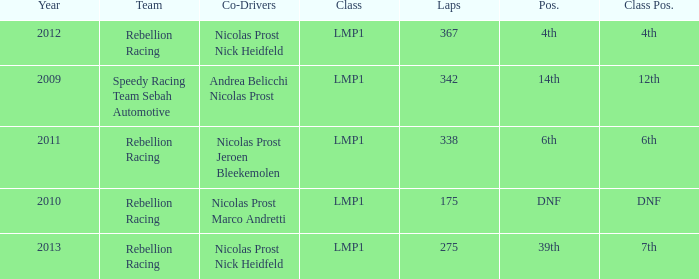What is Class Pos., when Year is before 2013, and when Laps is greater than 175? 12th, 6th, 4th. 